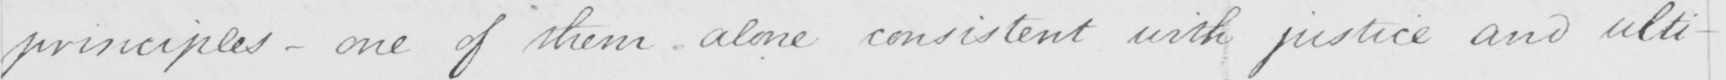What does this handwritten line say? principles  _  one of them alone consistent with justice and ulti- 